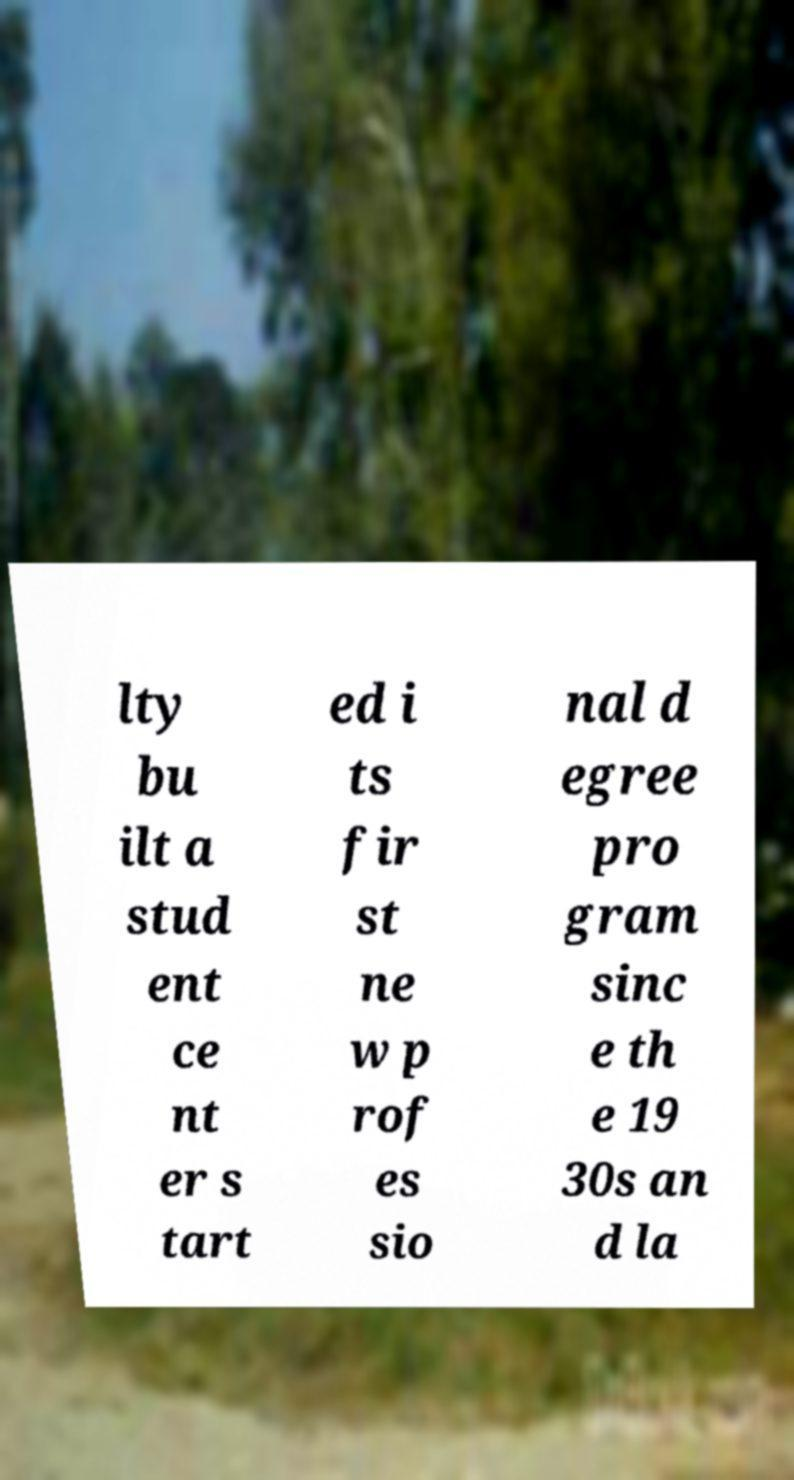What messages or text are displayed in this image? I need them in a readable, typed format. lty bu ilt a stud ent ce nt er s tart ed i ts fir st ne w p rof es sio nal d egree pro gram sinc e th e 19 30s an d la 